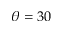Convert formula to latex. <formula><loc_0><loc_0><loc_500><loc_500>\theta = 3 0</formula> 